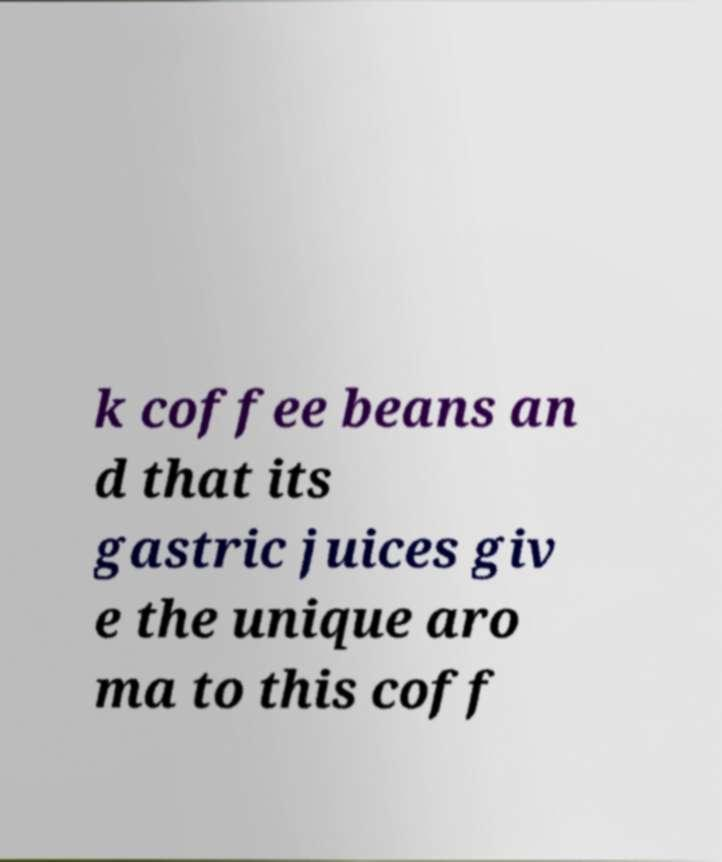I need the written content from this picture converted into text. Can you do that? k coffee beans an d that its gastric juices giv e the unique aro ma to this coff 